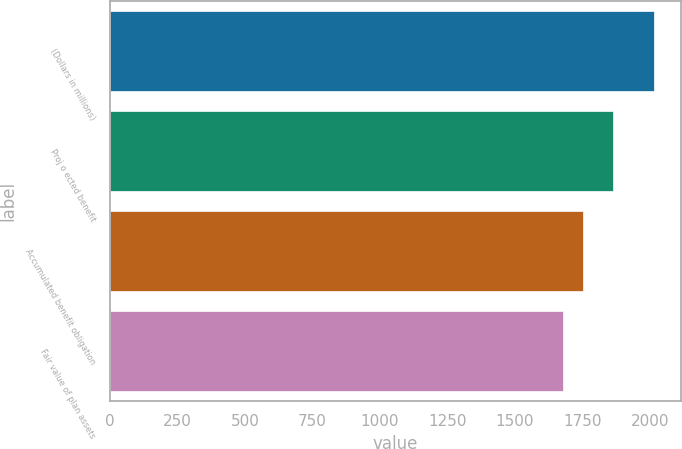<chart> <loc_0><loc_0><loc_500><loc_500><bar_chart><fcel>(Dollars in millions)<fcel>Proj o ected benefit<fcel>Accumulated benefit obligation<fcel>Fair value of plan assets<nl><fcel>2016<fcel>1865<fcel>1754<fcel>1680<nl></chart> 